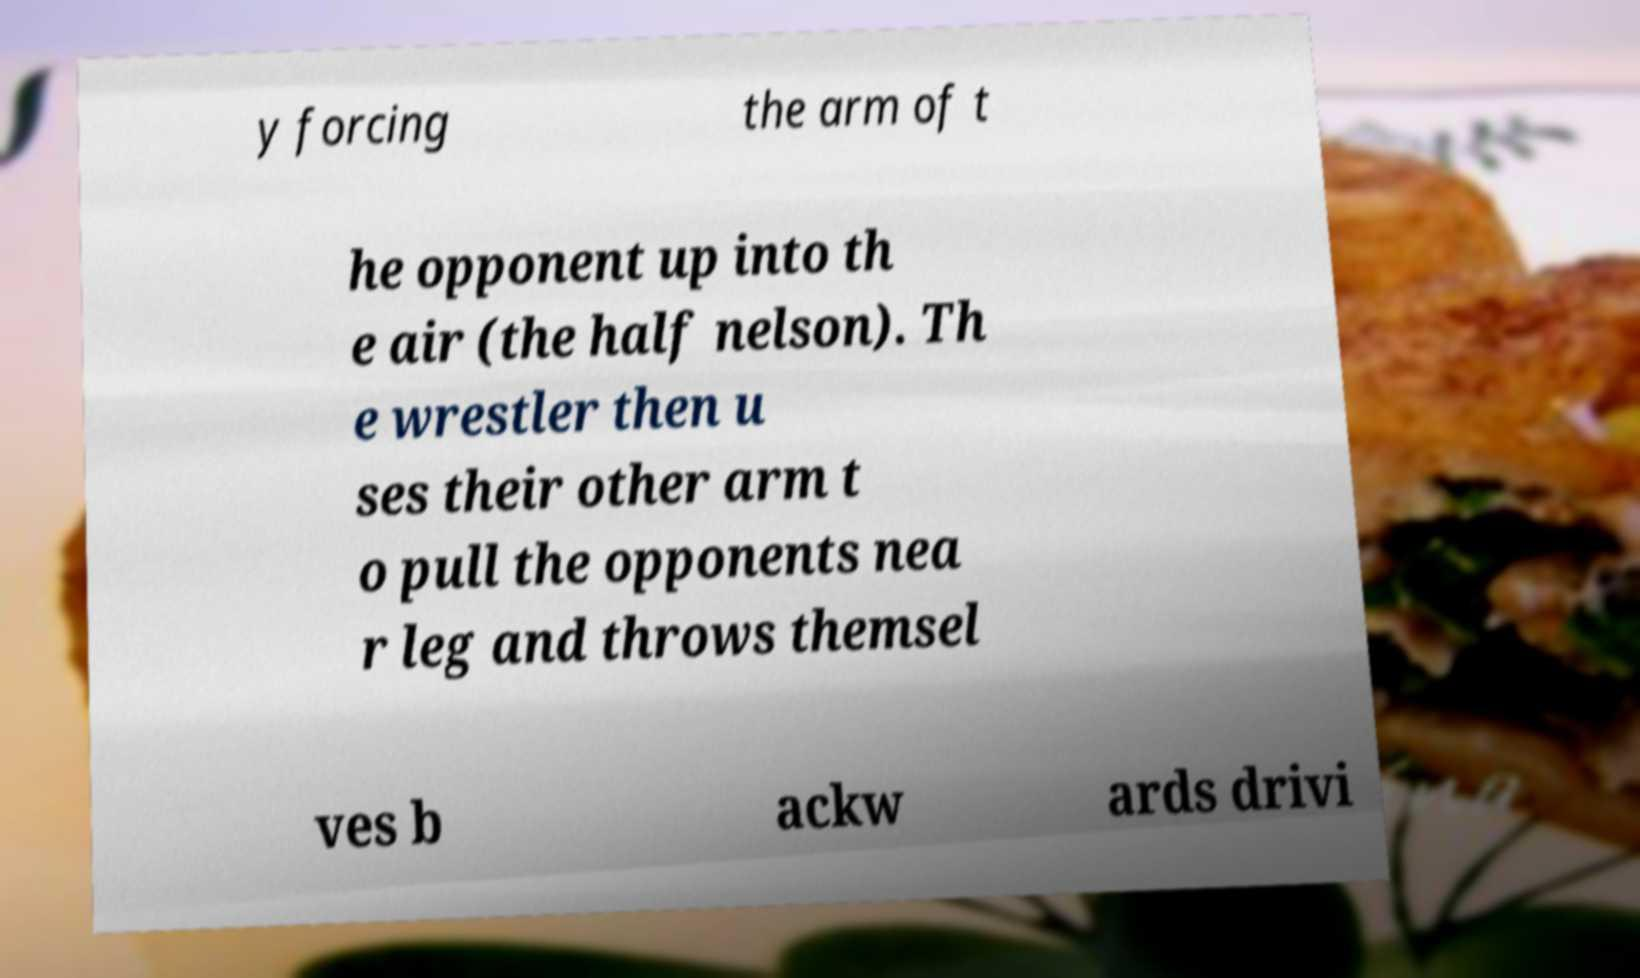Please read and relay the text visible in this image. What does it say? y forcing the arm of t he opponent up into th e air (the half nelson). Th e wrestler then u ses their other arm t o pull the opponents nea r leg and throws themsel ves b ackw ards drivi 